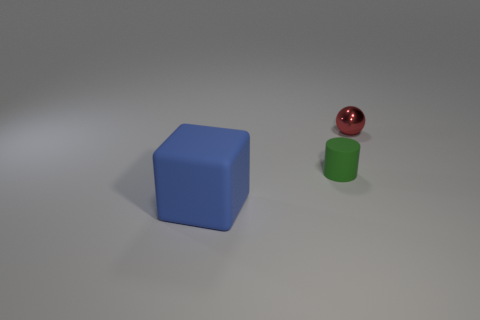Is there a gray cylinder made of the same material as the large blue cube?
Offer a very short reply. No. What number of objects are things that are behind the tiny rubber cylinder or objects that are in front of the small red ball?
Offer a very short reply. 3. There is a small thing in front of the shiny object; is its color the same as the tiny sphere?
Keep it short and to the point. No. What number of other objects are the same color as the matte cylinder?
Keep it short and to the point. 0. What is the material of the tiny cylinder?
Your response must be concise. Rubber. Does the object that is on the left side of the cylinder have the same size as the metallic ball?
Offer a terse response. No. Is there anything else that is the same size as the blue thing?
Provide a short and direct response. No. Are there the same number of shiny spheres that are behind the metallic ball and green rubber cylinders to the left of the matte cylinder?
Provide a succinct answer. Yes. How big is the object on the left side of the matte cylinder?
Provide a succinct answer. Large. Is the cylinder the same color as the rubber cube?
Offer a very short reply. No. 